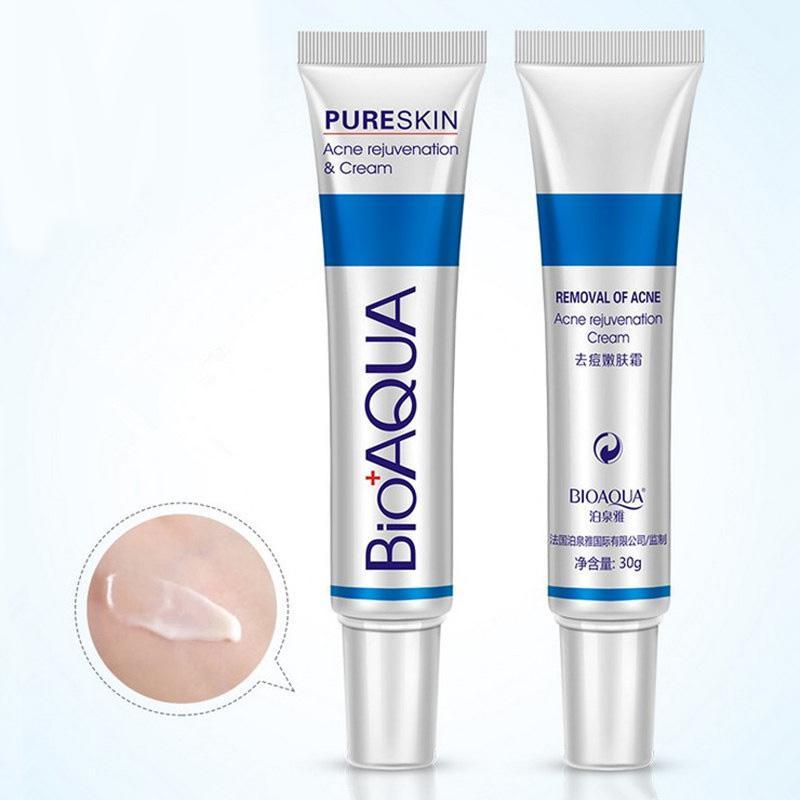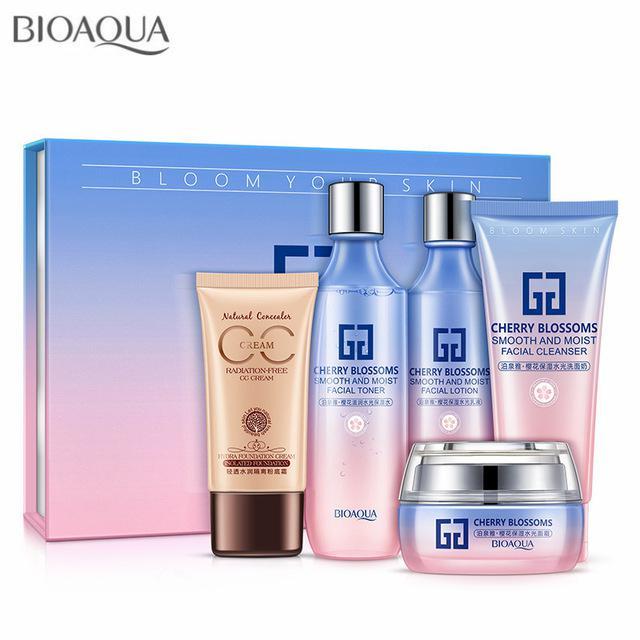The first image is the image on the left, the second image is the image on the right. Given the left and right images, does the statement "The right image shows a tube product standing on its cap to the right of its upright box." hold true? Answer yes or no. No. The first image is the image on the left, the second image is the image on the right. Analyze the images presented: Is the assertion "The left and right image contains the same number of  boxes and face cream bottles." valid? Answer yes or no. No. 